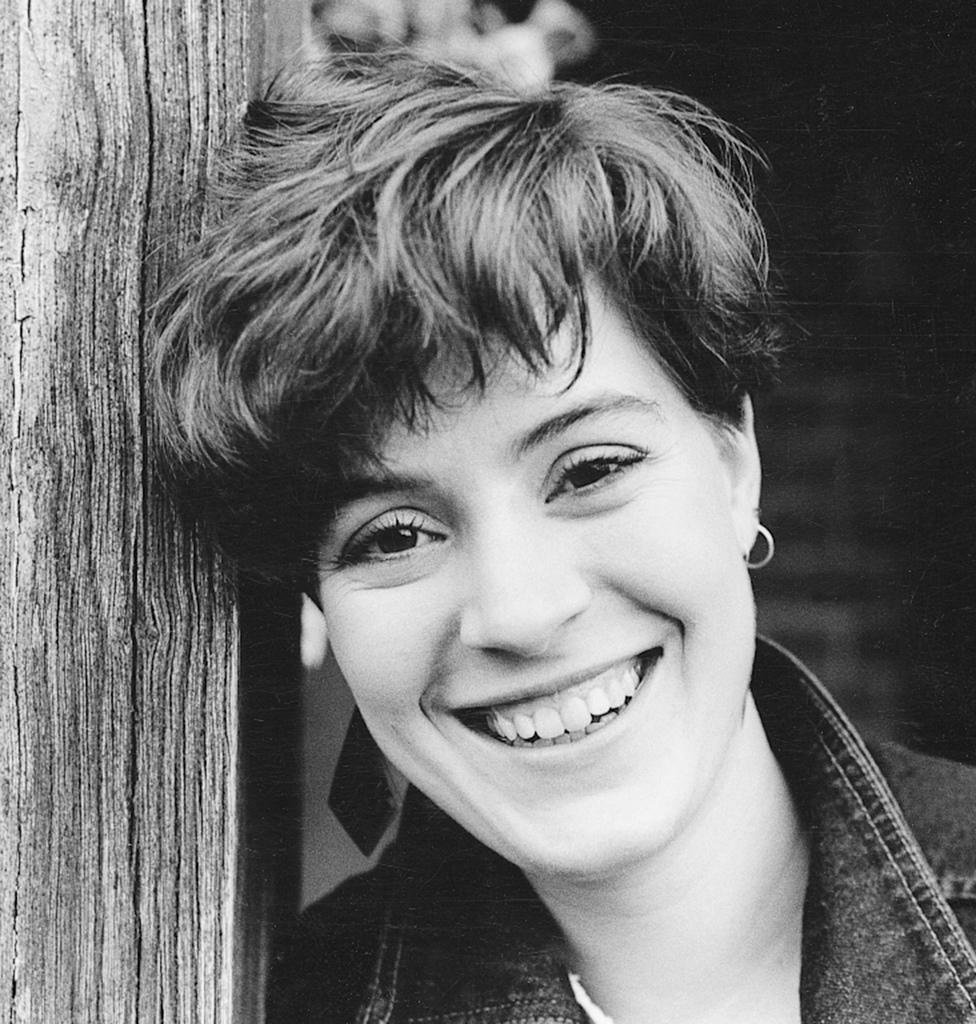In one or two sentences, can you explain what this image depicts? This is a black and white image. This image consists of a person. Only the face is visible. She is smiling. 